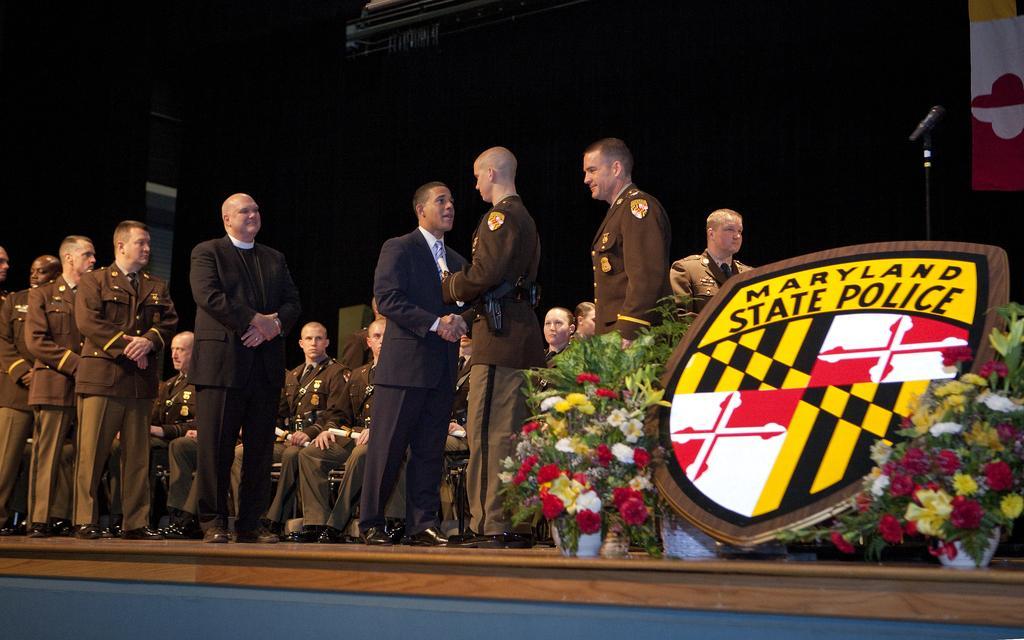Can you describe this image briefly? As we can see in the image there are group of people, flowers and there is a mic. 